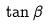Convert formula to latex. <formula><loc_0><loc_0><loc_500><loc_500>\tan \beta</formula> 